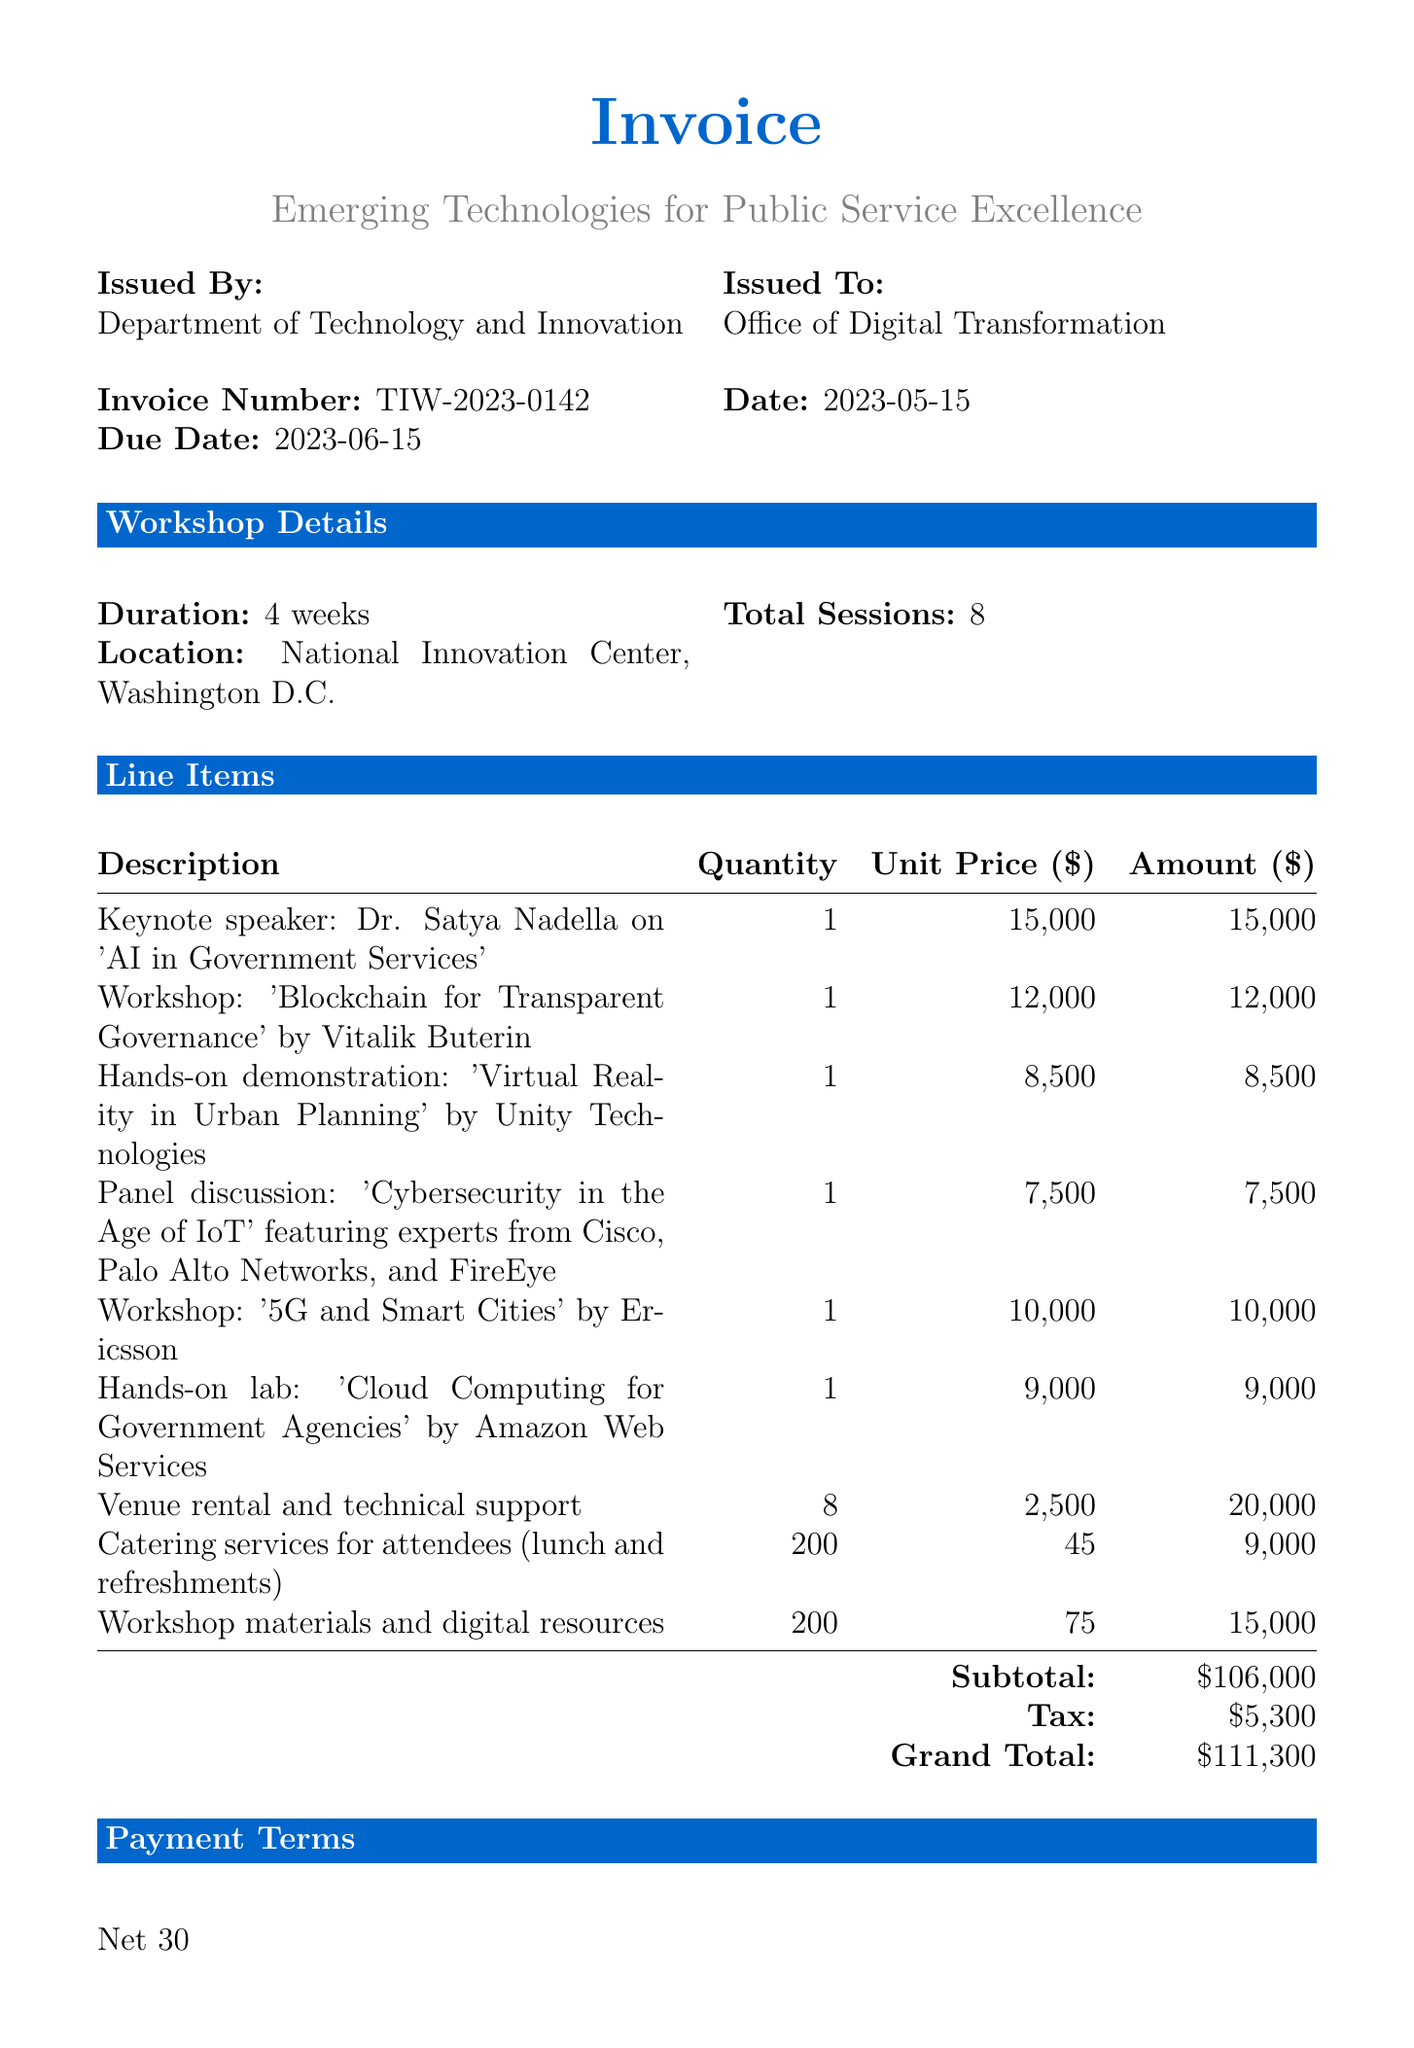What is the invoice number? The invoice number is a unique identifier for the transaction listed in the document.
Answer: TIW-2023-0142 What is the total amount due? The total amount due at the end of the invoice summarizes all costs associated with the workshop series.
Answer: $111,300 Who is the keynote speaker? The keynote speaker is a prominent figure mentioned in the document, featuring his name and topic.
Answer: Dr. Satya Nadella What is the duration of the workshop series? The duration specifies the time frame over which the workshop series takes place, as stated in the document.
Answer: 4 weeks How many total sessions were conducted in the workshop? The total sessions indicates the number of individual meetings or workshops held during the series.
Answer: 8 What is the subtotal amount before tax? The subtotal refers to the total calculated before taxes are added, as presented in the invoice.
Answer: $106,000 What is the due date for the payment? The due date indicates the last date on which the payment should be made, specified in the document.
Answer: 2023-06-15 Which location hosted the workshop series? The location mentions where the series took place, establishing the venue.
Answer: National Innovation Center, Washington D.C What service was provided by Unity Technologies? This outlines one of the hands-on demonstrations included in the program.
Answer: Virtual Reality in Urban Planning 